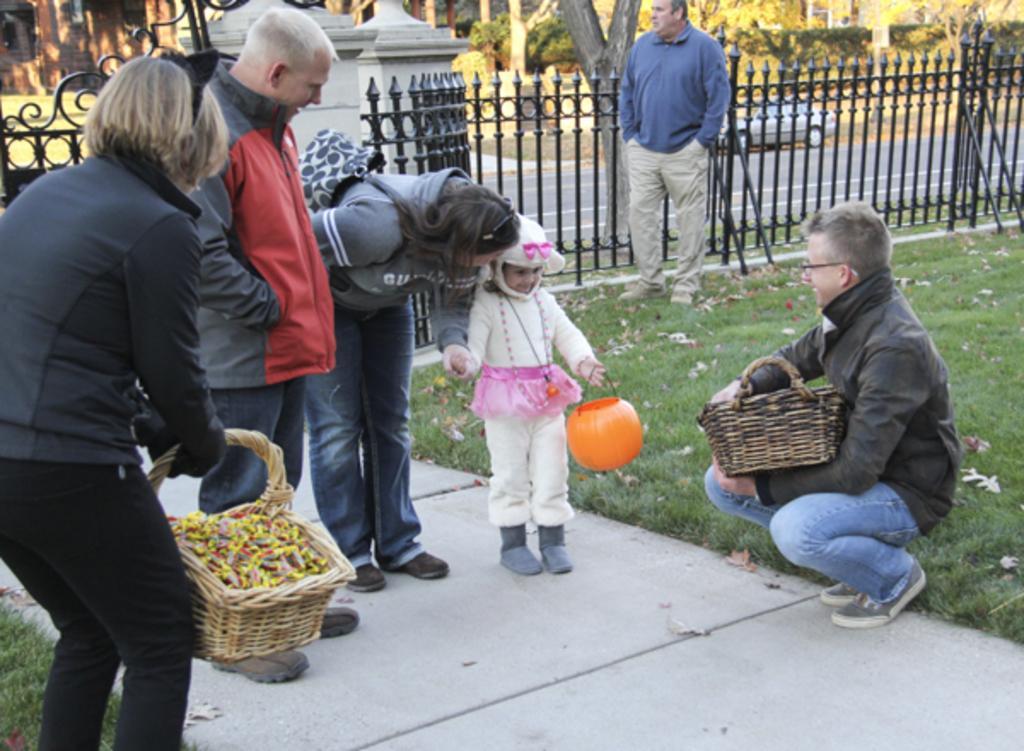Describe this image in one or two sentences. In this picture we can see people on the ground, here we can see baskets and some object and in the background we can see a fence, car, trees. 